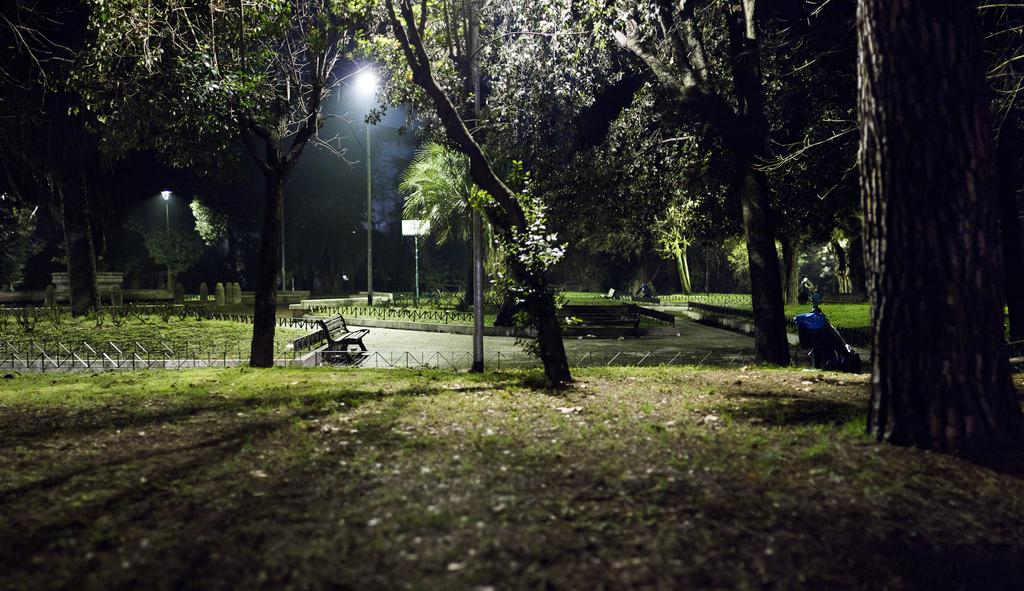What type of surface is visible in the image? There is a grass surface in the image. What can be seen growing on the grass surface? There are trees in the image. What feature is present in the middle of the image? There is a path in the image. What is located on the path? There is a bench on the path. What can be seen behind the path? There are trees visible behind the path. What structures are present in the image that provide illumination? There are poles with lights in the image. What type of flower is growing on the bench in the image? There are no flowers visible on the bench in the image. Can you describe the father sitting on the bench in the image? There is no father present in the image; only a bench is visible on the path. 